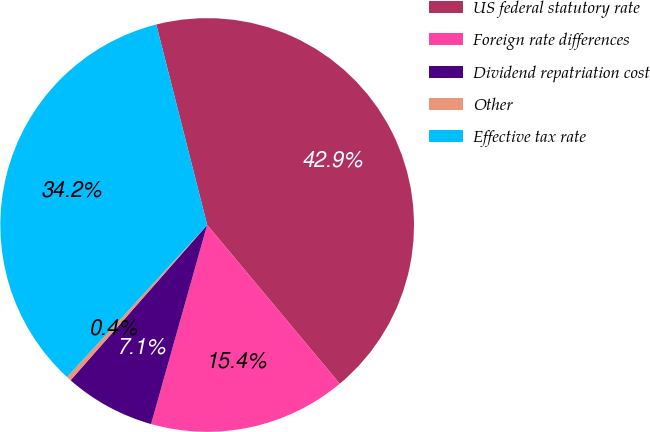Convert chart. <chart><loc_0><loc_0><loc_500><loc_500><pie_chart><fcel>US federal statutory rate<fcel>Foreign rate differences<fcel>Dividend repatriation cost<fcel>Other<fcel>Effective tax rate<nl><fcel>42.89%<fcel>15.44%<fcel>7.11%<fcel>0.37%<fcel>34.19%<nl></chart> 